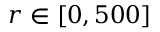Convert formula to latex. <formula><loc_0><loc_0><loc_500><loc_500>r \in [ 0 , 5 0 0 ]</formula> 